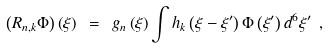<formula> <loc_0><loc_0><loc_500><loc_500>\left ( R _ { n , k } \Phi \right ) \left ( \xi \right ) \ = \ g _ { n } \left ( \xi \right ) \int h _ { k } \left ( \xi - \xi ^ { \prime } \right ) \Phi \left ( \xi ^ { \prime } \right ) d ^ { 6 } \xi ^ { \prime } \ ,</formula> 